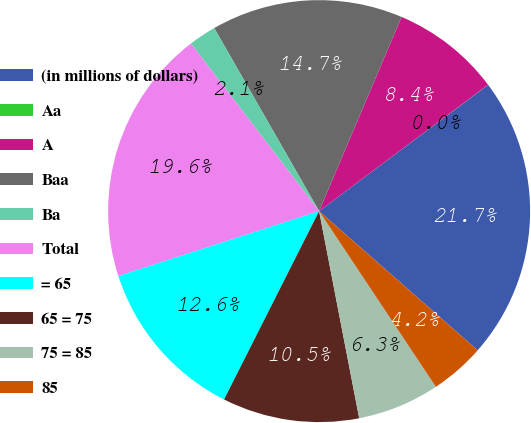Convert chart to OTSL. <chart><loc_0><loc_0><loc_500><loc_500><pie_chart><fcel>(in millions of dollars)<fcel>Aa<fcel>A<fcel>Baa<fcel>Ba<fcel>Total<fcel>= 65<fcel>65 = 75<fcel>75 = 85<fcel>85<nl><fcel>21.68%<fcel>0.01%<fcel>8.39%<fcel>14.67%<fcel>2.11%<fcel>19.59%<fcel>12.58%<fcel>10.48%<fcel>6.29%<fcel>4.2%<nl></chart> 